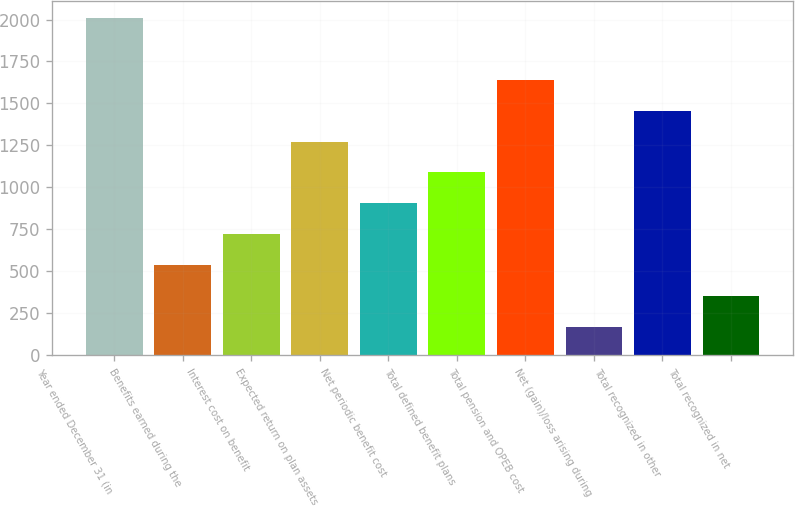Convert chart to OTSL. <chart><loc_0><loc_0><loc_500><loc_500><bar_chart><fcel>Year ended December 31 (in<fcel>Benefits earned during the<fcel>Interest cost on benefit<fcel>Expected return on plan assets<fcel>Net periodic benefit cost<fcel>Total defined benefit plans<fcel>Total pension and OPEB cost<fcel>Net (gain)/loss arising during<fcel>Total recognized in other<fcel>Total recognized in net<nl><fcel>2009<fcel>536.2<fcel>720.3<fcel>1272.6<fcel>904.4<fcel>1088.5<fcel>1640.8<fcel>168<fcel>1456.7<fcel>352.1<nl></chart> 